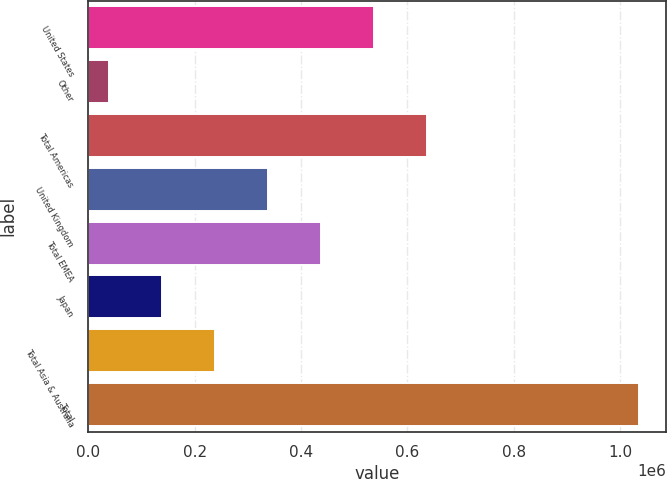<chart> <loc_0><loc_0><loc_500><loc_500><bar_chart><fcel>United States<fcel>Other<fcel>Total Americas<fcel>United Kingdom<fcel>Total EMEA<fcel>Japan<fcel>Total Asia & Australia<fcel>Total<nl><fcel>537160<fcel>38653<fcel>636861<fcel>337757<fcel>437459<fcel>138354<fcel>238056<fcel>1.03567e+06<nl></chart> 